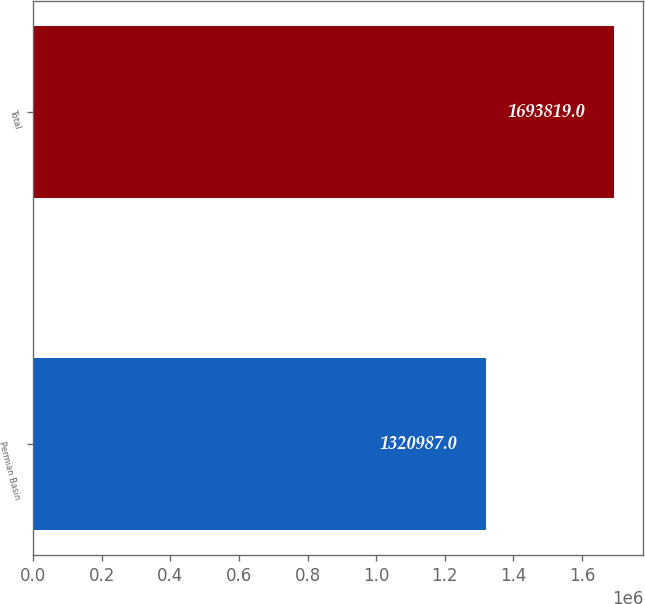Convert chart to OTSL. <chart><loc_0><loc_0><loc_500><loc_500><bar_chart><fcel>Permian Basin<fcel>Total<nl><fcel>1.32099e+06<fcel>1.69382e+06<nl></chart> 